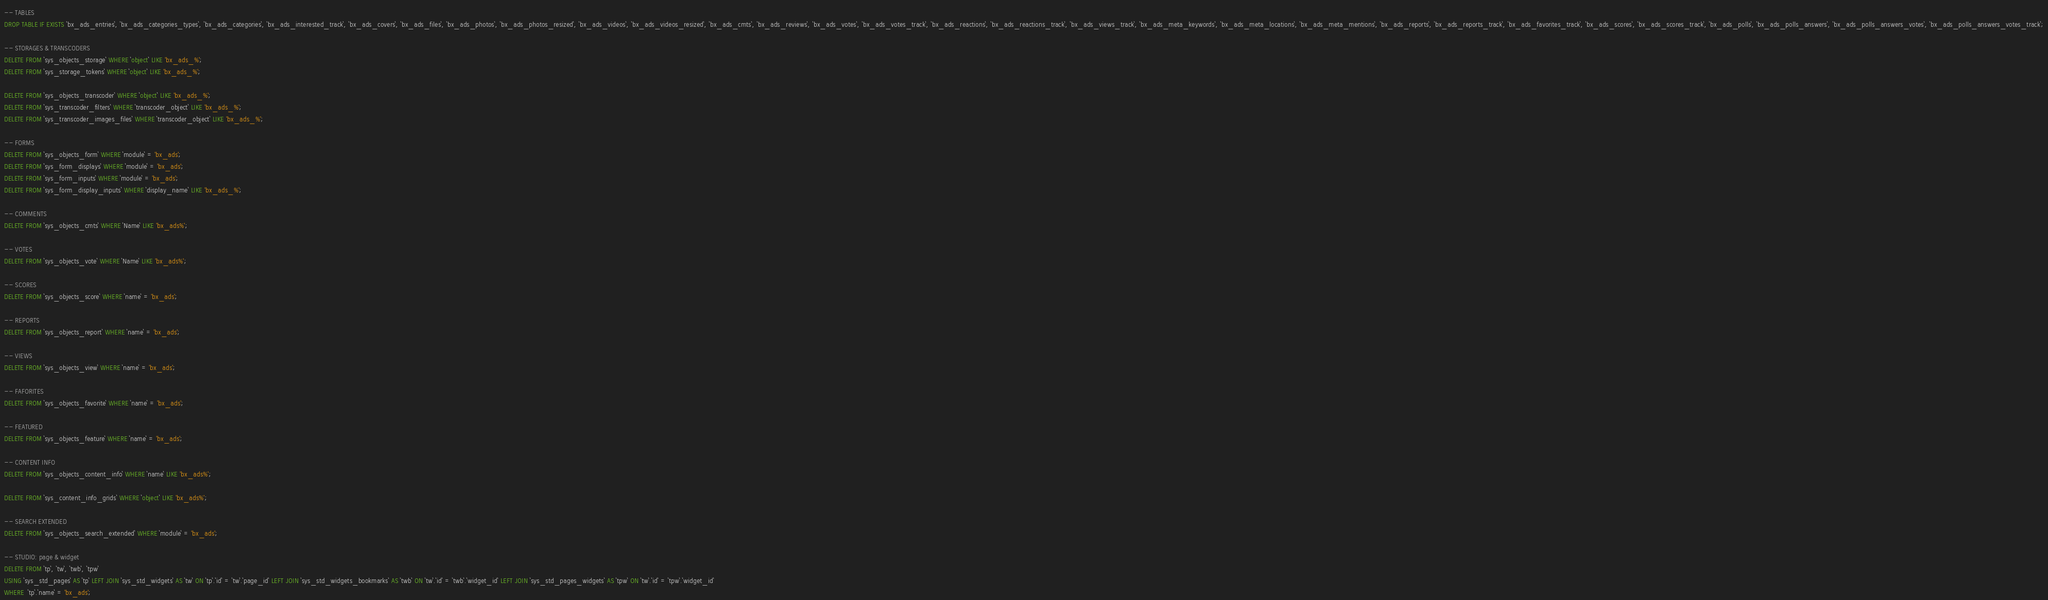<code> <loc_0><loc_0><loc_500><loc_500><_SQL_>
-- TABLES
DROP TABLE IF EXISTS `bx_ads_entries`, `bx_ads_categories_types`, `bx_ads_categories`, `bx_ads_interested_track`, `bx_ads_covers`, `bx_ads_files`, `bx_ads_photos`, `bx_ads_photos_resized`, `bx_ads_videos`, `bx_ads_videos_resized`, `bx_ads_cmts`, `bx_ads_reviews`, `bx_ads_votes`, `bx_ads_votes_track`, `bx_ads_reactions`, `bx_ads_reactions_track`, `bx_ads_views_track`, `bx_ads_meta_keywords`, `bx_ads_meta_locations`, `bx_ads_meta_mentions`, `bx_ads_reports`, `bx_ads_reports_track`, `bx_ads_favorites_track`, `bx_ads_scores`, `bx_ads_scores_track`, `bx_ads_polls`, `bx_ads_polls_answers`, `bx_ads_polls_answers_votes`, `bx_ads_polls_answers_votes_track`;

-- STORAGES & TRANSCODERS
DELETE FROM `sys_objects_storage` WHERE `object` LIKE 'bx_ads_%';
DELETE FROM `sys_storage_tokens` WHERE `object` LIKE 'bx_ads_%';

DELETE FROM `sys_objects_transcoder` WHERE `object` LIKE 'bx_ads_%';
DELETE FROM `sys_transcoder_filters` WHERE `transcoder_object` LIKE 'bx_ads_%';
DELETE FROM `sys_transcoder_images_files` WHERE `transcoder_object` LIKE 'bx_ads_%';

-- FORMS
DELETE FROM `sys_objects_form` WHERE `module` = 'bx_ads';
DELETE FROM `sys_form_displays` WHERE `module` = 'bx_ads';
DELETE FROM `sys_form_inputs` WHERE `module` = 'bx_ads';
DELETE FROM `sys_form_display_inputs` WHERE `display_name` LIKE 'bx_ads_%';

-- COMMENTS
DELETE FROM `sys_objects_cmts` WHERE `Name` LIKE 'bx_ads%';

-- VOTES
DELETE FROM `sys_objects_vote` WHERE `Name` LIKE 'bx_ads%';

-- SCORES
DELETE FROM `sys_objects_score` WHERE `name` = 'bx_ads';

-- REPORTS
DELETE FROM `sys_objects_report` WHERE `name` = 'bx_ads';

-- VIEWS
DELETE FROM `sys_objects_view` WHERE `name` = 'bx_ads';

-- FAFORITES
DELETE FROM `sys_objects_favorite` WHERE `name` = 'bx_ads';

-- FEATURED
DELETE FROM `sys_objects_feature` WHERE `name` = 'bx_ads';

-- CONTENT INFO
DELETE FROM `sys_objects_content_info` WHERE `name` LIKE 'bx_ads%';

DELETE FROM `sys_content_info_grids` WHERE `object` LIKE 'bx_ads%';

-- SEARCH EXTENDED
DELETE FROM `sys_objects_search_extended` WHERE `module` = 'bx_ads';

-- STUDIO: page & widget
DELETE FROM `tp`, `tw`, `twb`, `tpw` 
USING `sys_std_pages` AS `tp` LEFT JOIN `sys_std_widgets` AS `tw` ON `tp`.`id` = `tw`.`page_id` LEFT JOIN `sys_std_widgets_bookmarks` AS `twb` ON `tw`.`id` = `twb`.`widget_id` LEFT JOIN `sys_std_pages_widgets` AS `tpw` ON `tw`.`id` = `tpw`.`widget_id`
WHERE  `tp`.`name` = 'bx_ads';
</code> 